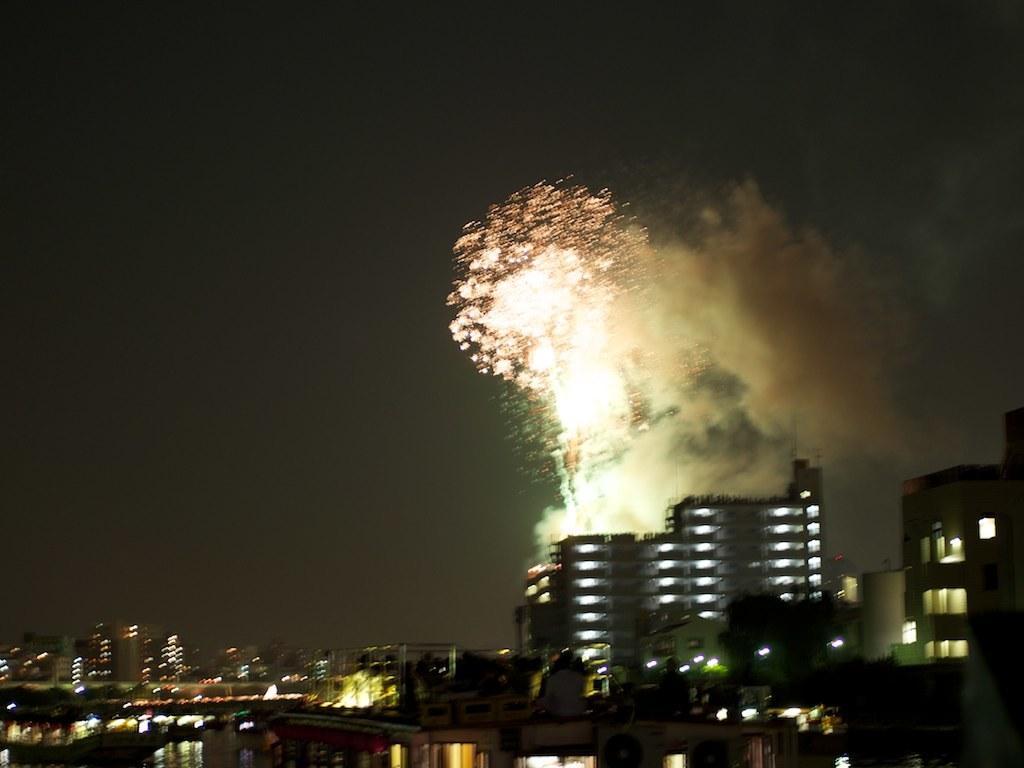Could you give a brief overview of what you see in this image? In this image we can see a group of buildings, water and in the background we can see the sky. 